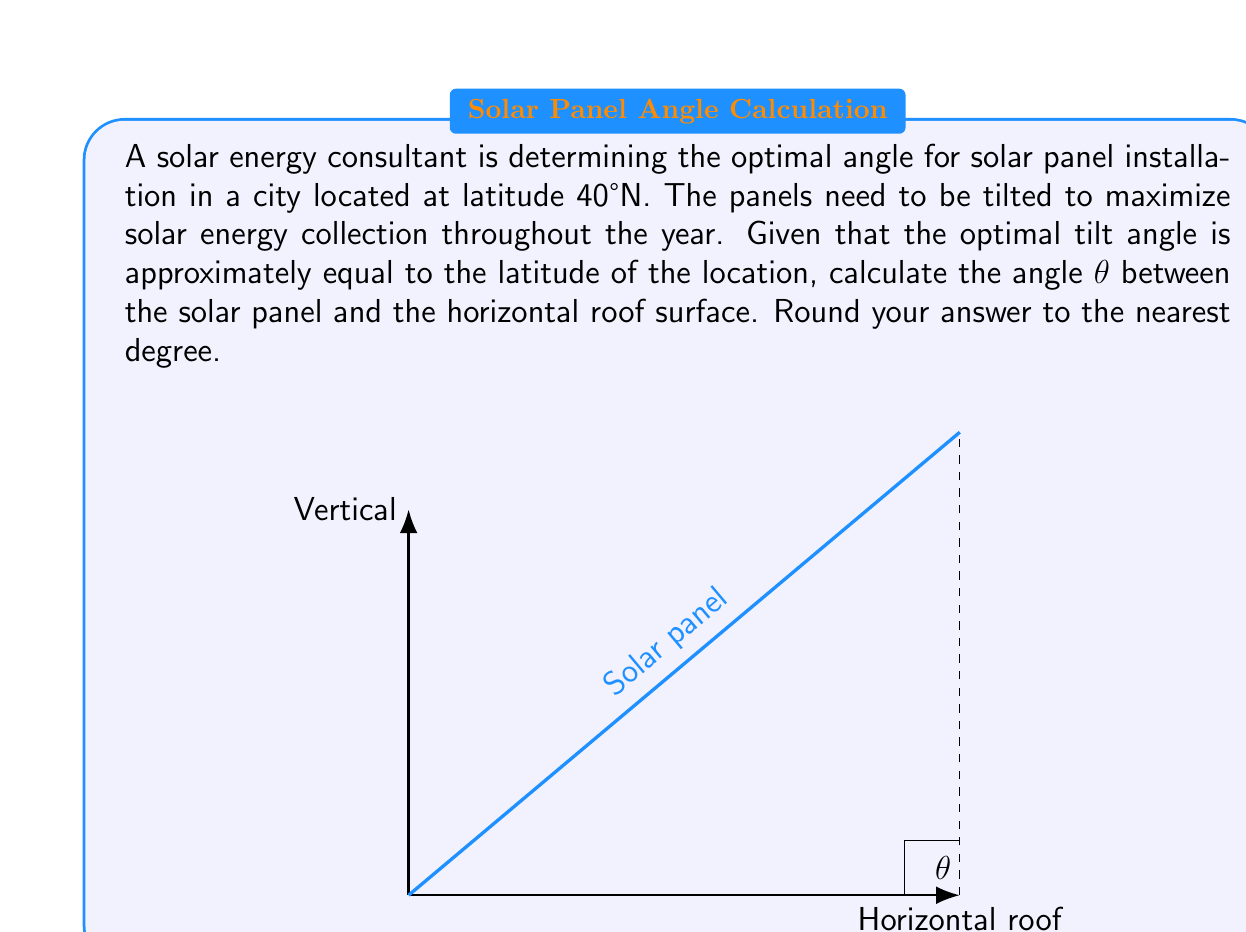Give your solution to this math problem. To solve this problem, we'll use the given information and basic trigonometry:

1) The optimal tilt angle for solar panels is approximately equal to the latitude of the location.

2) The city is located at latitude 40°N.

3) The angle θ we're looking for is the complement of the tilt angle, as it's measured from the horizontal roof surface.

Let's proceed step by step:

1) Optimal tilt angle ≈ Latitude = 40°

2) The angle θ and the tilt angle form a right angle (90°), so they are complementary angles.

3) We can find θ using the following equation:
   
   $$ \theta + \text{Tilt Angle} = 90° $$

4) Substituting the known value:
   
   $$ \theta + 40° = 90° $$

5) Solving for θ:
   
   $$ \theta = 90° - 40° = 50° $$

Therefore, the angle θ between the solar panel and the horizontal roof surface should be 50°.
Answer: 50° 